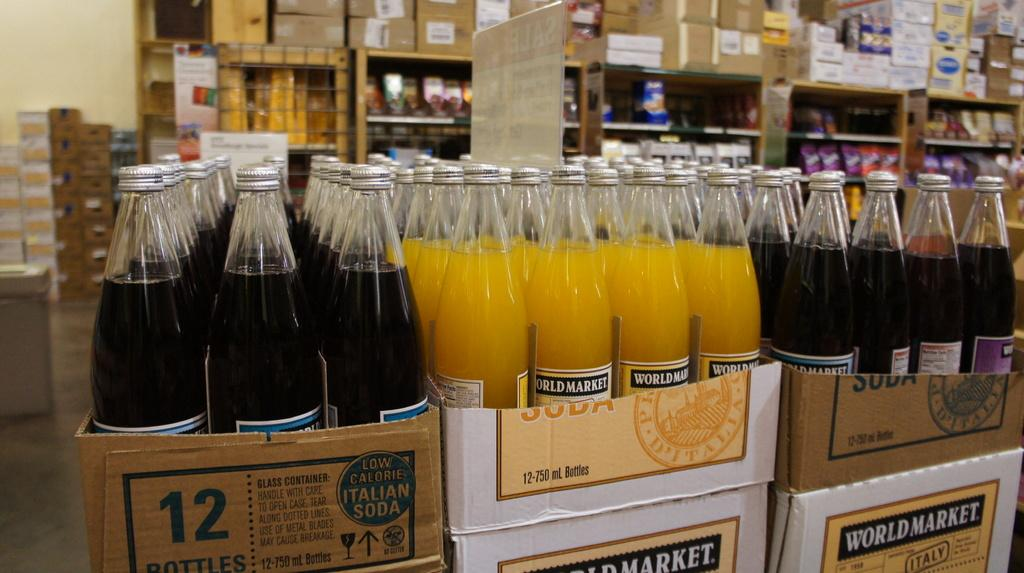<image>
Create a compact narrative representing the image presented. A lot of bottles are stacked on top of a World Market box. 